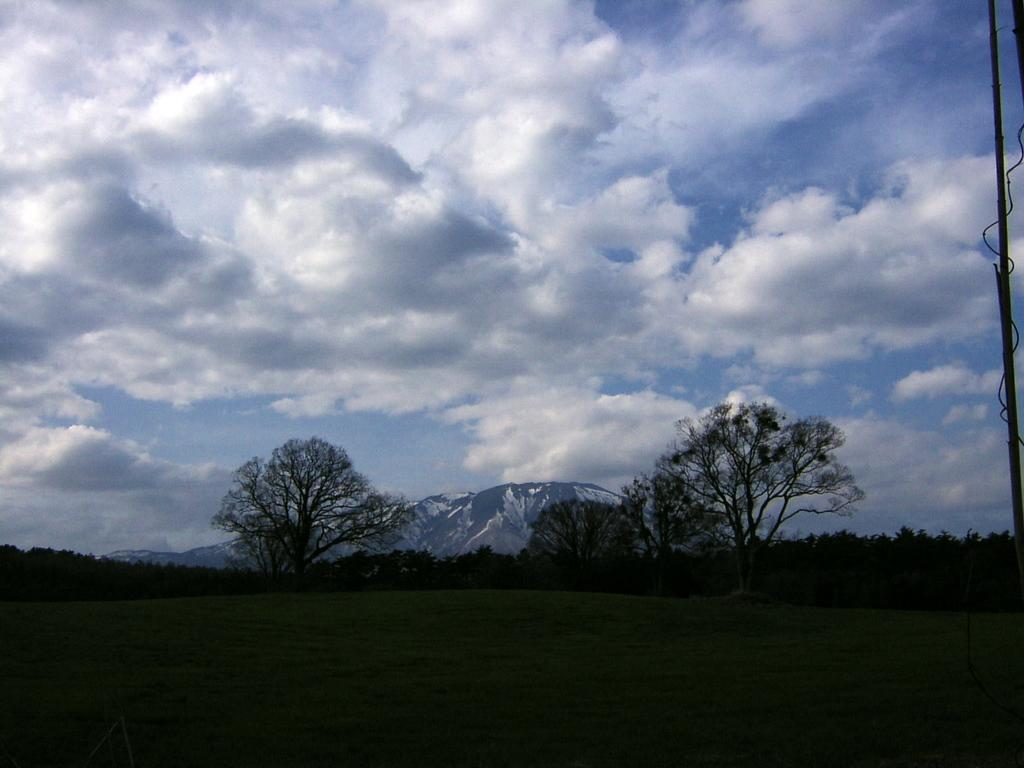What type of landscape is depicted in the image? There is a meadow in the image. What can be seen in the background of the meadow? There are trees and hills in the background of the image. What is visible above the meadow and background? The sky is visible in the image. What can be observed in the sky? Clouds are present in the sky. How many girls are playing in the circle with their pets in the image? There are no girls, circles, or pets present in the image; it features a meadow, trees, hills, sky, and clouds. 